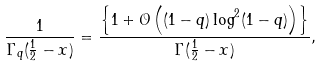Convert formula to latex. <formula><loc_0><loc_0><loc_500><loc_500>\frac { 1 } { \Gamma _ { q } ( \frac { 1 } { 2 } - x ) } = \frac { \left \{ 1 + \mathcal { O } \left ( ( 1 - q ) \log ^ { 2 } ( 1 - q ) \right ) \right \} } { \Gamma ( \frac { 1 } { 2 } - x ) } ,</formula> 